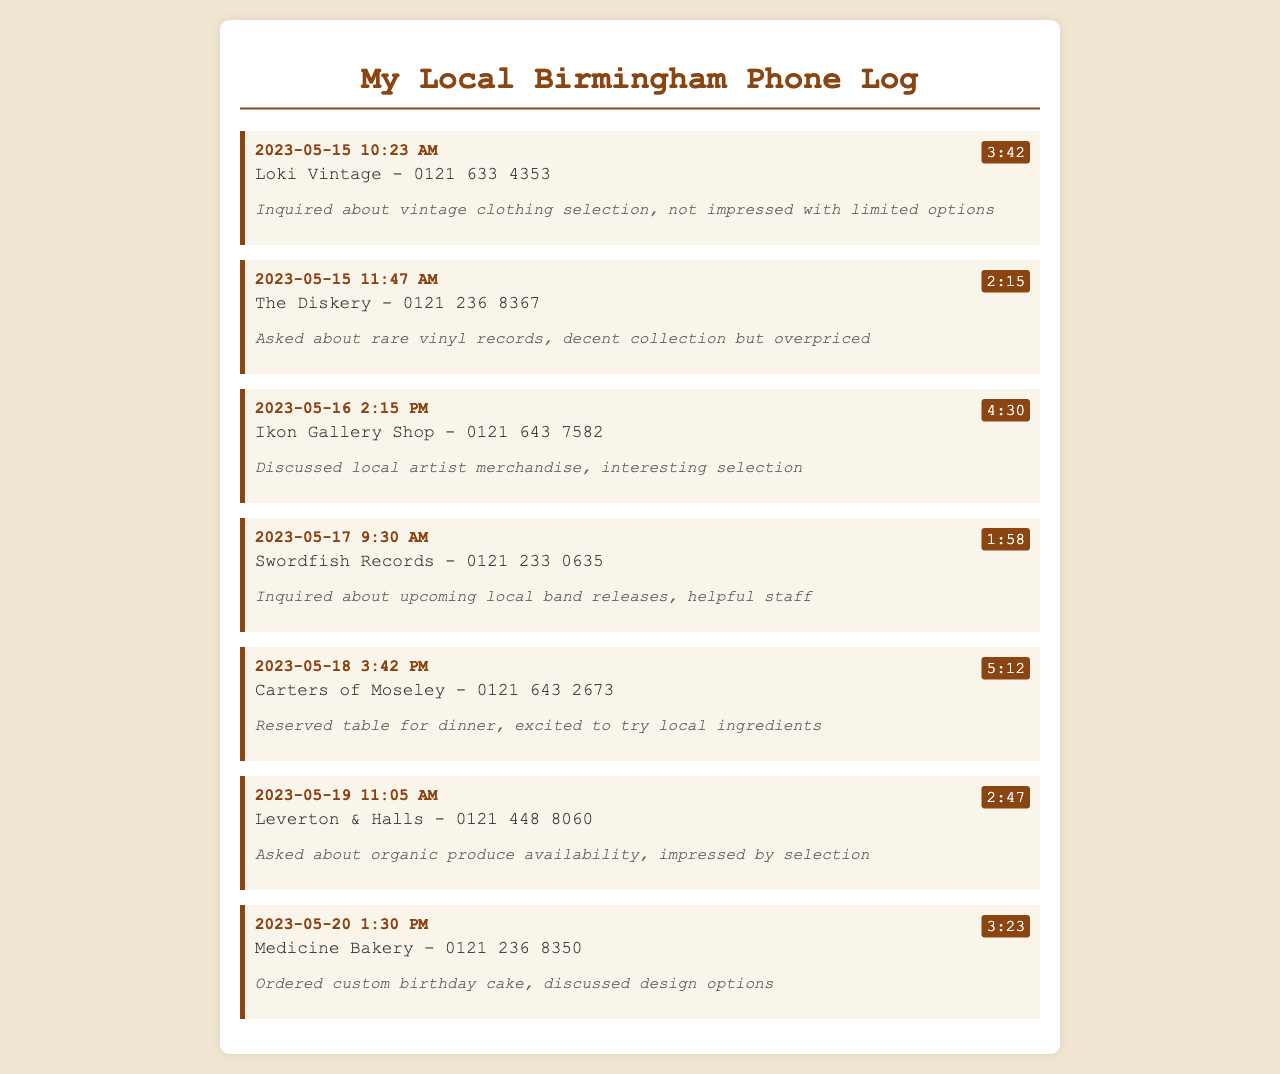what is the first business listed? The first business in the log is the one recorded on May 15, 2023, at 10:23 AM, which is Loki Vintage.
Answer: Loki Vintage how long was the call with The Diskery? The call duration for The Diskery is shown as 2 minutes and 15 seconds.
Answer: 2:15 what did the caller think of the vintage clothing selection at Loki Vintage? The notes for Loki Vintage indicate that the caller was not impressed with the limited options available.
Answer: not impressed with limited options which business has a phone number starting with 0121 643? There are two businesses with that area code: Ikon Gallery Shop and Carters of Moseley.
Answer: Ikon Gallery Shop, Carters of Moseley on what date was a custom birthday cake ordered? The custom birthday cake order was made on May 20, 2023, which is explicitly mentioned in the call log.
Answer: May 20, 2023 who was helpful in providing information about upcoming local band releases? The staff at Swordfish Records were noted as helpful during the call.
Answer: helpful staff what did the caller reserve a table for at Carters of Moseley? The caller reserved a table for dinner, as stated in the notes.
Answer: dinner how long was the longest call in the log? The longest call mentioned is to Carters of Moseley, lasting 5 minutes and 12 seconds.
Answer: 5:12 